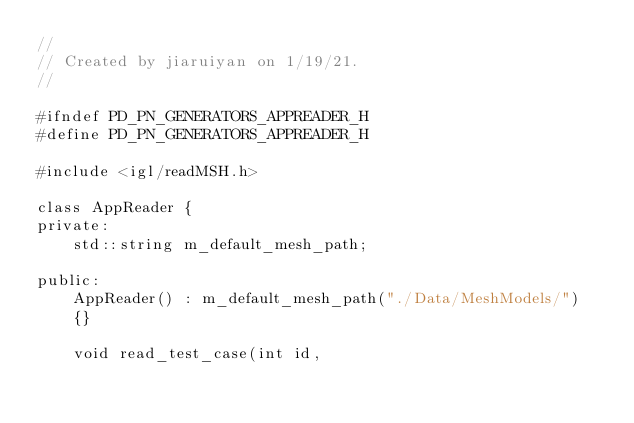Convert code to text. <code><loc_0><loc_0><loc_500><loc_500><_C_>//
// Created by jiaruiyan on 1/19/21.
//

#ifndef PD_PN_GENERATORS_APPREADER_H
#define PD_PN_GENERATORS_APPREADER_H

#include <igl/readMSH.h>

class AppReader {
private:
    std::string m_default_mesh_path;

public:
    AppReader() : m_default_mesh_path("./Data/MeshModels/")
    {}

    void read_test_case(int id,</code> 